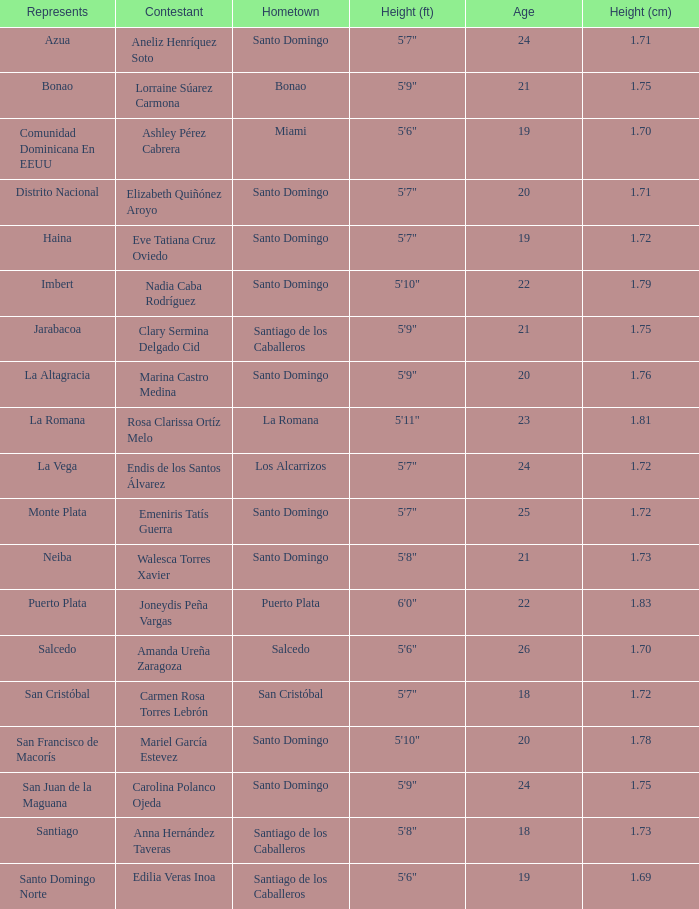Name the least age for distrito nacional 20.0. 